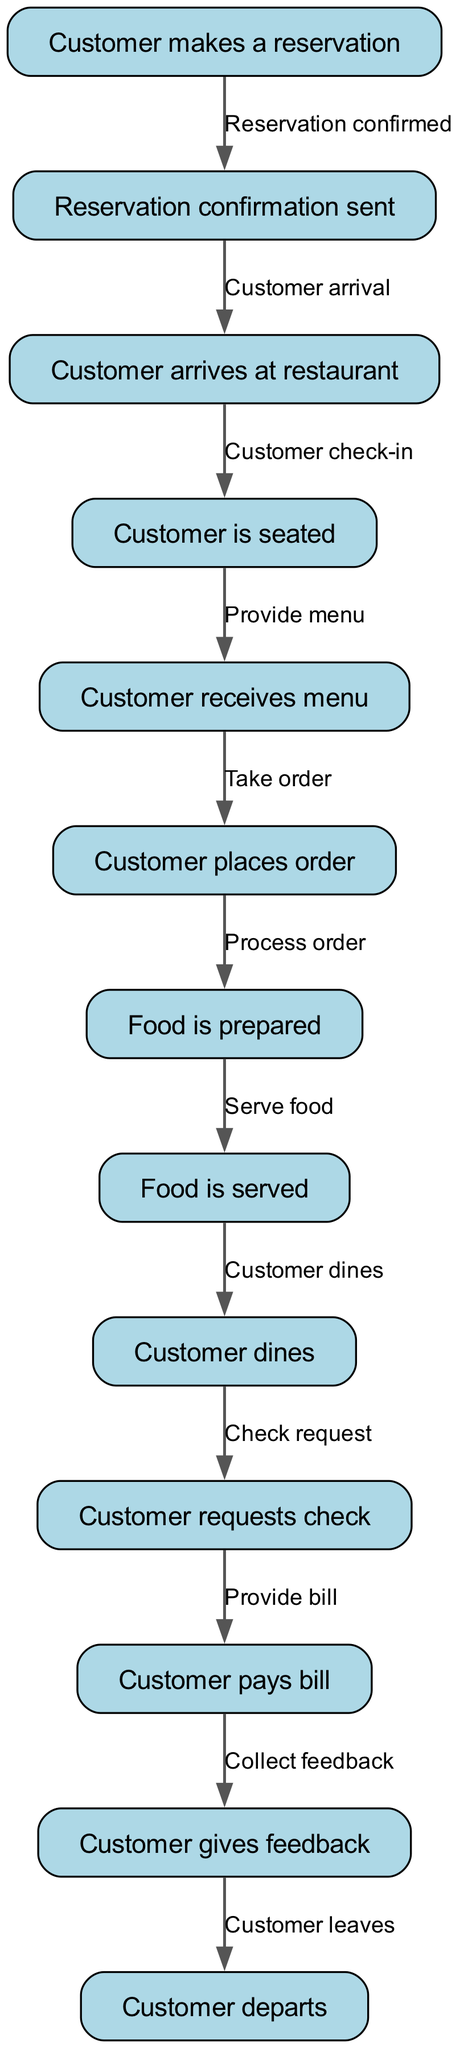What is the first step in the dining experience? The first step is represented by the node "Customer makes a reservation." This node initiates the entire process, indicating that the customer's journey in the dining experience begins with making a reservation.
Answer: Customer makes a reservation How many nodes are there in the diagram? By counting all the distinct stages represented in the diagram, there are 12 nodes. Each node signifies a unique step in the customer's dining experience.
Answer: 12 What happens after the customer arrives at the restaurant? The flowchart indicates that after the "Customer arrives at restaurant," the next node is "Customer is seated." This shows a clear progression from arriving to getting seated.
Answer: Customer is seated What is the final step of the customer’s dining experience? The last node in the diagram is "Customer departs," which signifies the conclusion of the dining experience after all other steps have been completed.
Answer: Customer departs What action occurs between food preparation and serving? The diagram indicates that "Food is served" follows the "Food is prepared" step. This outlines the direct sequence of actions that lead from the preparation of food to its serving.
Answer: Serve food What is the relationship between ordering and food preparation? The relationship is that "Customer places order" leads to "Food is prepared." This indicates that the order placement triggers the preparation of the food.
Answer: Process order How many edges are present in the diagram? By analyzing the connections between the nodes, there are 11 edges. Each edge represents the flow from one step to the next in the dining experience process.
Answer: 11 What does the customer do after dining? Following the "Customer dines" step, the next action is "Customer requests check." This flow illustrates the clear sequence of what happens post-dining.
Answer: Check request What is the interaction at the "menu" node? At the "menu" node, the action expressed is "Take order." This represents the interaction where the customer's selection from the menu leads to them placing an order.
Answer: Take order 